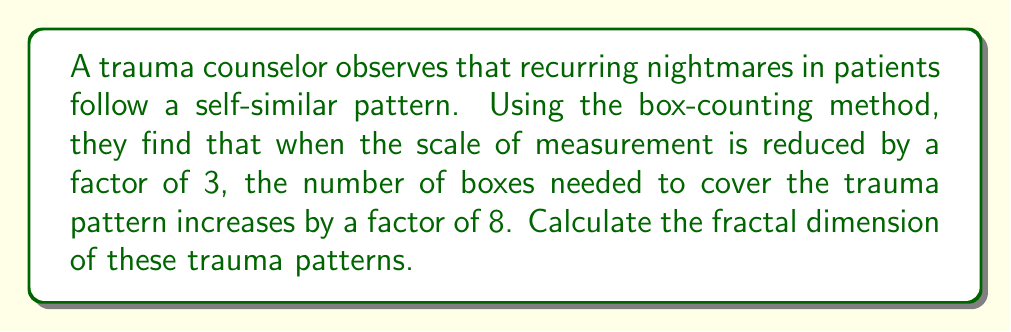Could you help me with this problem? To calculate the fractal dimension using the box-counting method, we use the following steps:

1. Let's define our variables:
   $N$ = number of boxes
   $r$ = scale factor
   $D$ = fractal dimension

2. The fundamental relationship in the box-counting method is:

   $$N = r^{-D}$$

3. In this case, we're told that when $r = \frac{1}{3}$, $N = 8$. Let's substitute these values:

   $$8 = (\frac{1}{3})^{-D}$$

4. To solve for $D$, we take the logarithm of both sides:

   $$\log 8 = -D \log (\frac{1}{3})$$

5. Simplify the right side:

   $$\log 8 = D \log 3$$

6. Now we can solve for $D$:

   $$D = \frac{\log 8}{\log 3}$$

7. Calculate the value:

   $$D = \frac{\log 8}{\log 3} \approx 1.8928$$

This fractal dimension between 1 and 2 suggests that the trauma patterns in recurring nightmares have a complexity greater than a simple line (dimension 1) but less than a filled plane (dimension 2).
Answer: $D = \frac{\log 8}{\log 3} \approx 1.8928$ 